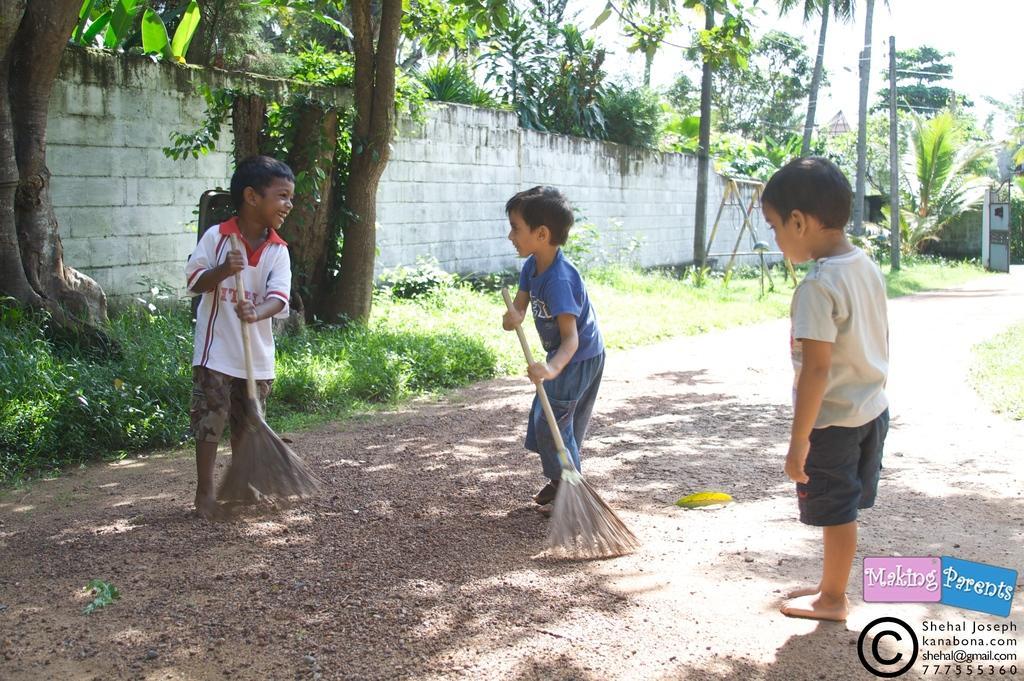Please provide a concise description of this image. In this image I can see three children wearing t shirt and shorts are standing on the road and I can see two of them are holding sticks in their hands and cleaning the road. In the background I can see some grass, few trees, the wall, few poles and the sky. 